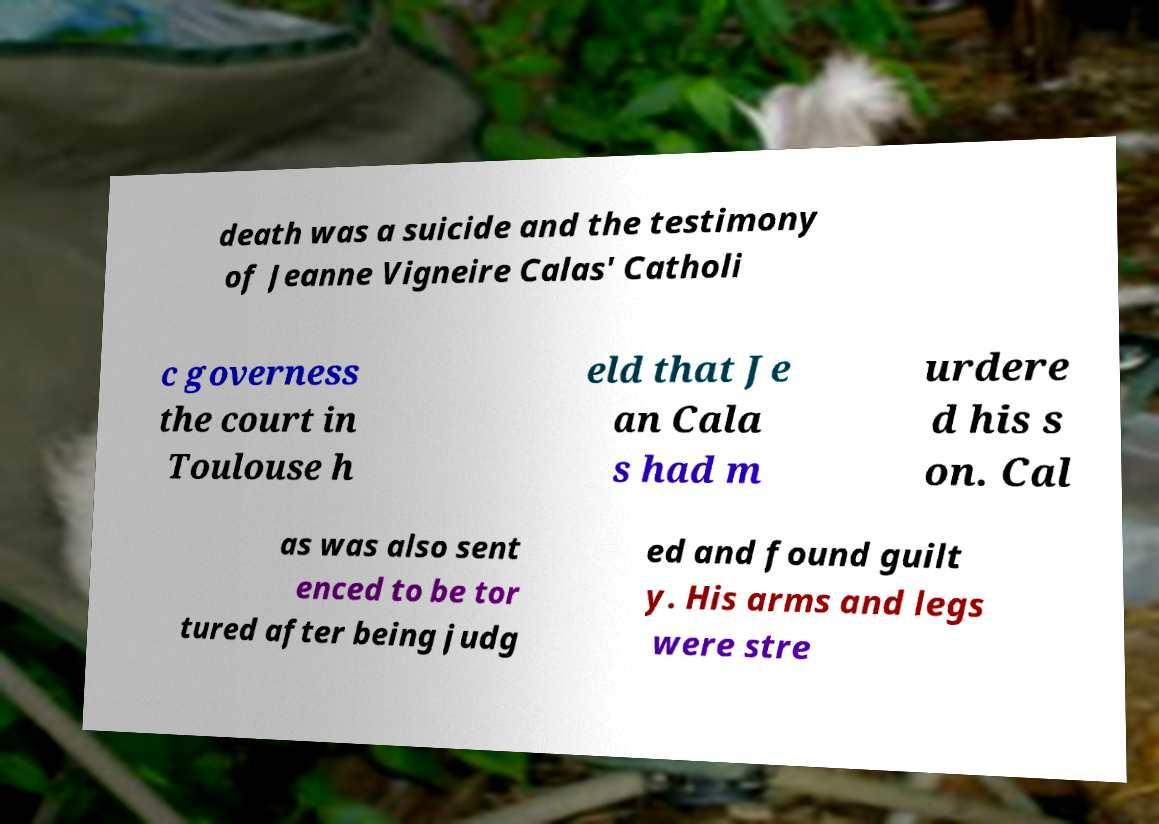I need the written content from this picture converted into text. Can you do that? death was a suicide and the testimony of Jeanne Vigneire Calas' Catholi c governess the court in Toulouse h eld that Je an Cala s had m urdere d his s on. Cal as was also sent enced to be tor tured after being judg ed and found guilt y. His arms and legs were stre 